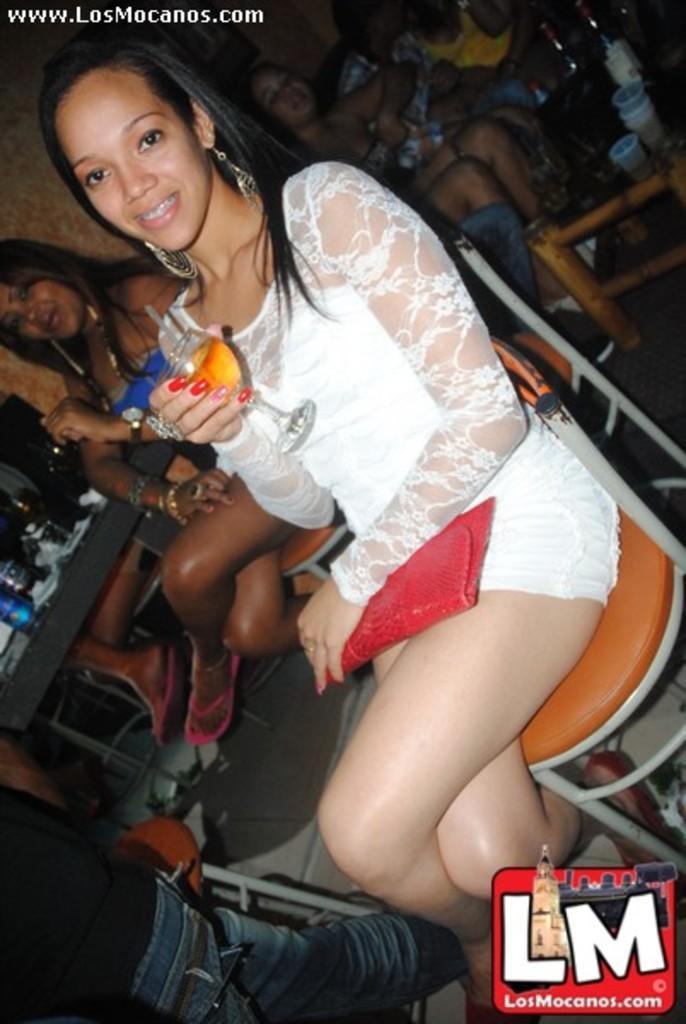Can you describe this image briefly? This picture is clicked inside the room. In the foreground we can see a woman wearing white color dress, smiling, holding a glass of drink and carrying a wallet and sitting on the chair. On the left we can see the group of people sitting on the chairs and we can see the tables on the top of which glasses of drinks and bottles are placed. In the bottom left corner there is a person seems to be walking on the ground. In the background we can see the wall and the group of people seems to be sitting on the chairs. In the bottom right corner we can see the watermark on the image. In the top left corner there is a text on the image. 